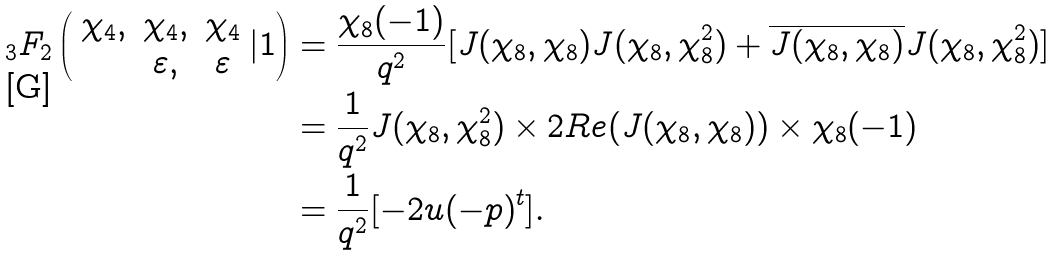Convert formula to latex. <formula><loc_0><loc_0><loc_500><loc_500>{ _ { 3 } } F _ { 2 } \left ( \begin{array} { c c c } \chi _ { 4 } , & \chi _ { 4 } , & \chi _ { 4 } \\ & \varepsilon , & \varepsilon \end{array} | 1 \right ) & = \frac { \chi _ { 8 } ( - 1 ) } { q ^ { 2 } } [ J ( \chi _ { 8 } , \chi _ { 8 } ) J ( \chi _ { 8 } , \chi _ { 8 } ^ { 2 } ) + \overline { J ( \chi _ { 8 } , \chi _ { 8 } ) } J ( \chi _ { 8 } , \chi _ { 8 } ^ { 2 } ) ] \\ & = \frac { 1 } { q ^ { 2 } } J ( \chi _ { 8 } , \chi _ { 8 } ^ { 2 } ) \times 2 R e ( J ( \chi _ { 8 } , \chi _ { 8 } ) ) \times \chi _ { 8 } ( - 1 ) \\ & = \frac { 1 } { q ^ { 2 } } [ - 2 u ( - p ) ^ { t } ] .</formula> 